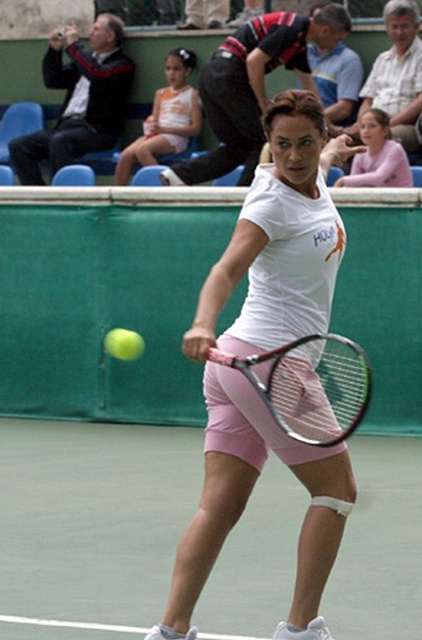Describe the objects in this image and their specific colors. I can see people in gray, darkgray, and maroon tones, people in gray, black, and maroon tones, tennis racket in gray, darkgray, and black tones, people in gray, black, maroon, and darkgray tones, and people in gray, darkgray, lightgray, and black tones in this image. 